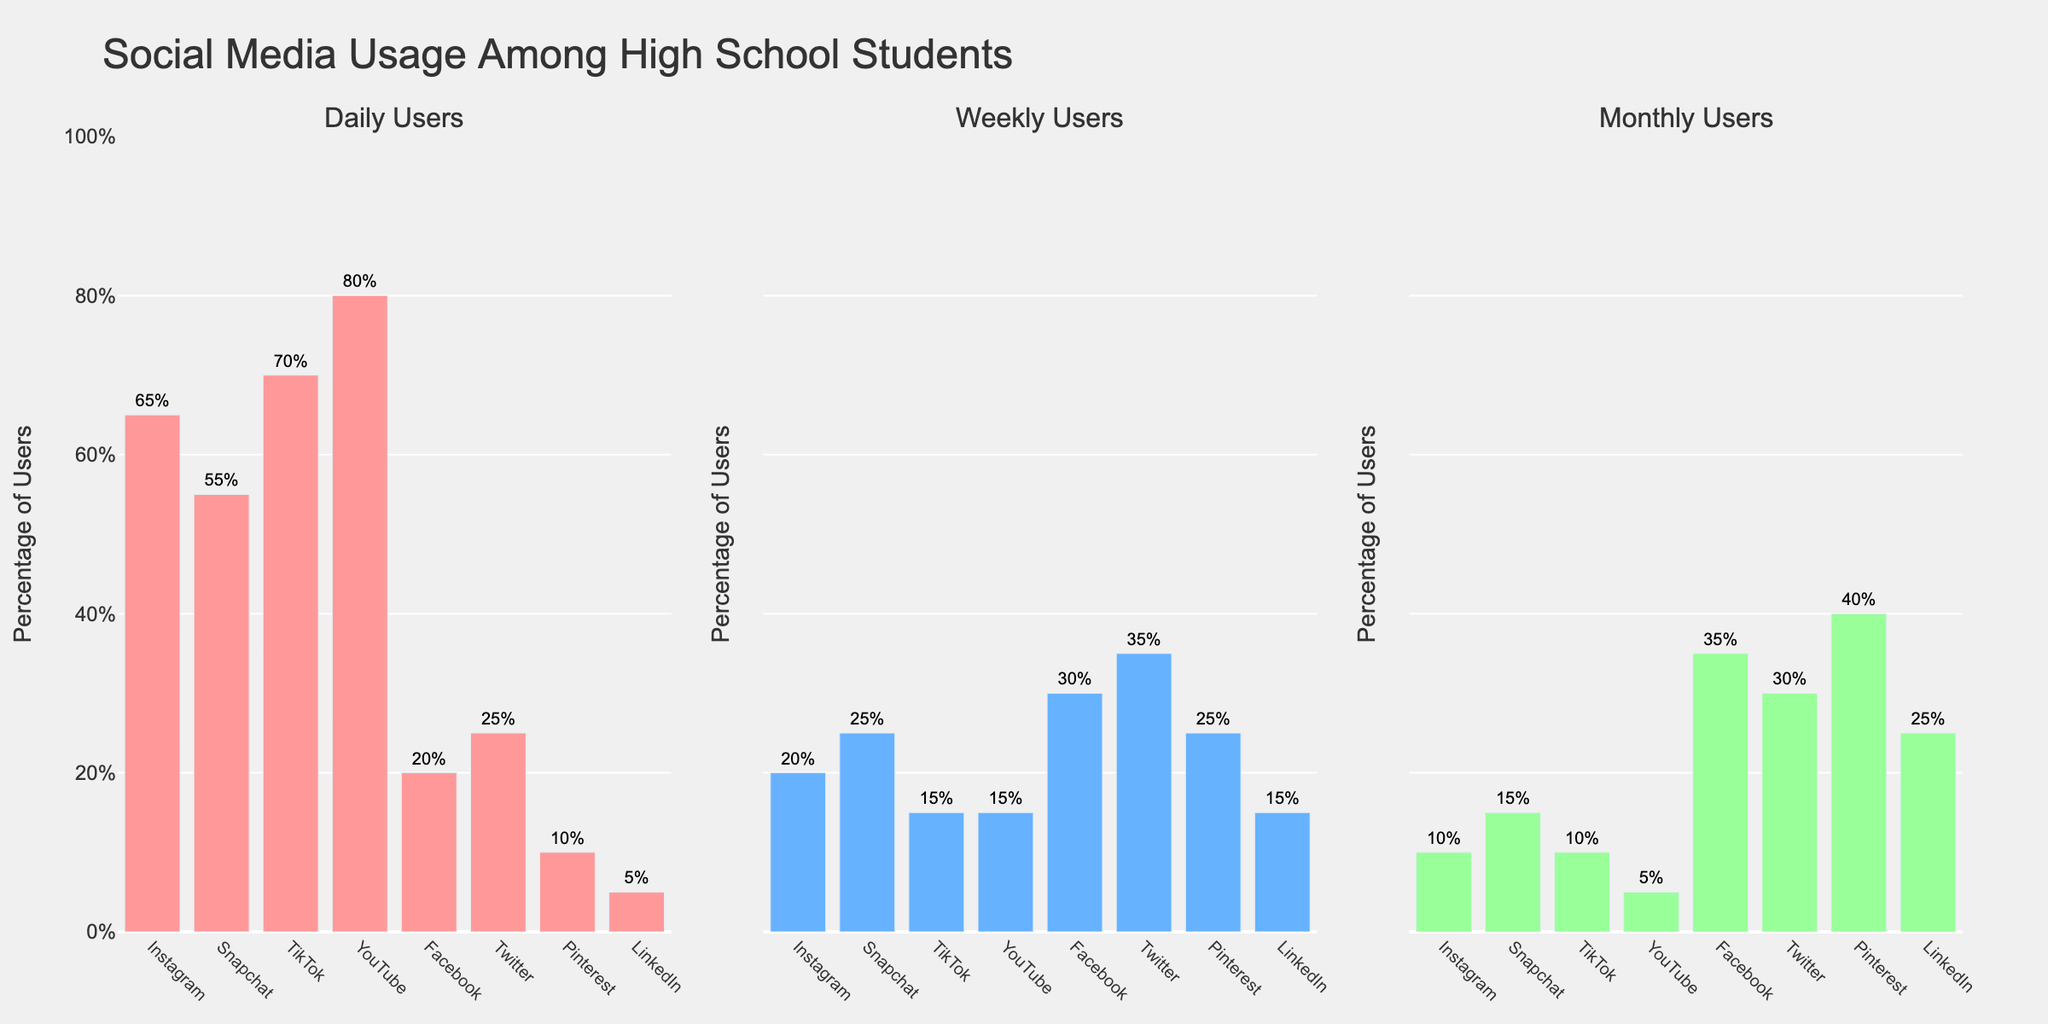How many platforms have at least 30% weekly users? First, identify the 'Weekly Users (%)' column. From the figure, count platforms with values equal to or greater than 30%. Platforms meeting this criterion are: Facebook, Twitter, and Pinterest.
Answer: 3 Which platform has the highest percentage of daily users? Look at the 'Daily Users' subplot. The platform with the tallest bar is YouTube.
Answer: YouTube What's the difference in monthly user percentages between Instagram and Facebook? Find the bars representing 'Monthly Users' for both Instagram and Facebook. Instagram has 10%, and Facebook has 35%. The difference is 35% - 10% = 25%.
Answer: 25% Compare the weekly users of Snapchat and TikTok. Which has more, and by how much? Locate the 'Weekly Users' bars for both Snapchat and TikTok. Snapchat has 25%, and TikTok has 15%. Snapchat has 10% more weekly users.
Answer: Snapchat by 10% What is the combined percentage of monthly users for Twitter and Pinterest? Sum the percentages of 'Monthly Users' for Twitter (30%) and Pinterest (40%). The total is 30% + 40% = 70%.
Answer: 70% Which platforms have fewer than 50% daily users? Identify 'Daily Users' bars less than 50%. Platforms meeting this criterion are Facebook, Twitter, Pinterest, and LinkedIn.
Answer: Facebook, Twitter, Pinterest, LinkedIn How does LinkedIn rank in terms of daily users compared to other platforms? Compare the 'Daily Users' bar for LinkedIn (5%) to others. LinkedIn has the lowest percentage of daily users.
Answer: Lowest Which platform has the closest percentage of monthly users to YouTube? Locate the 'Monthly Users' for YouTube (5%) and find the closest value. LinkedIn has 25%, which is closest considering the provided options.
Answer: LinkedIn What are the most and least popular platforms based on daily users, and what are their percentages? Find the platforms with the highest and lowest 'Daily Users' from the chart. The highest is YouTube at 80%, and the lowest is LinkedIn at 5%.
Answer: Most: YouTube (80%), Least: LinkedIn (5%) If you sum the percentages of daily, weekly, and monthly users for Instagram, what do you get? Add up the values for Instagram: 65% (daily) + 20% (weekly) + 10% (monthly) to get 95%.
Answer: 95% 